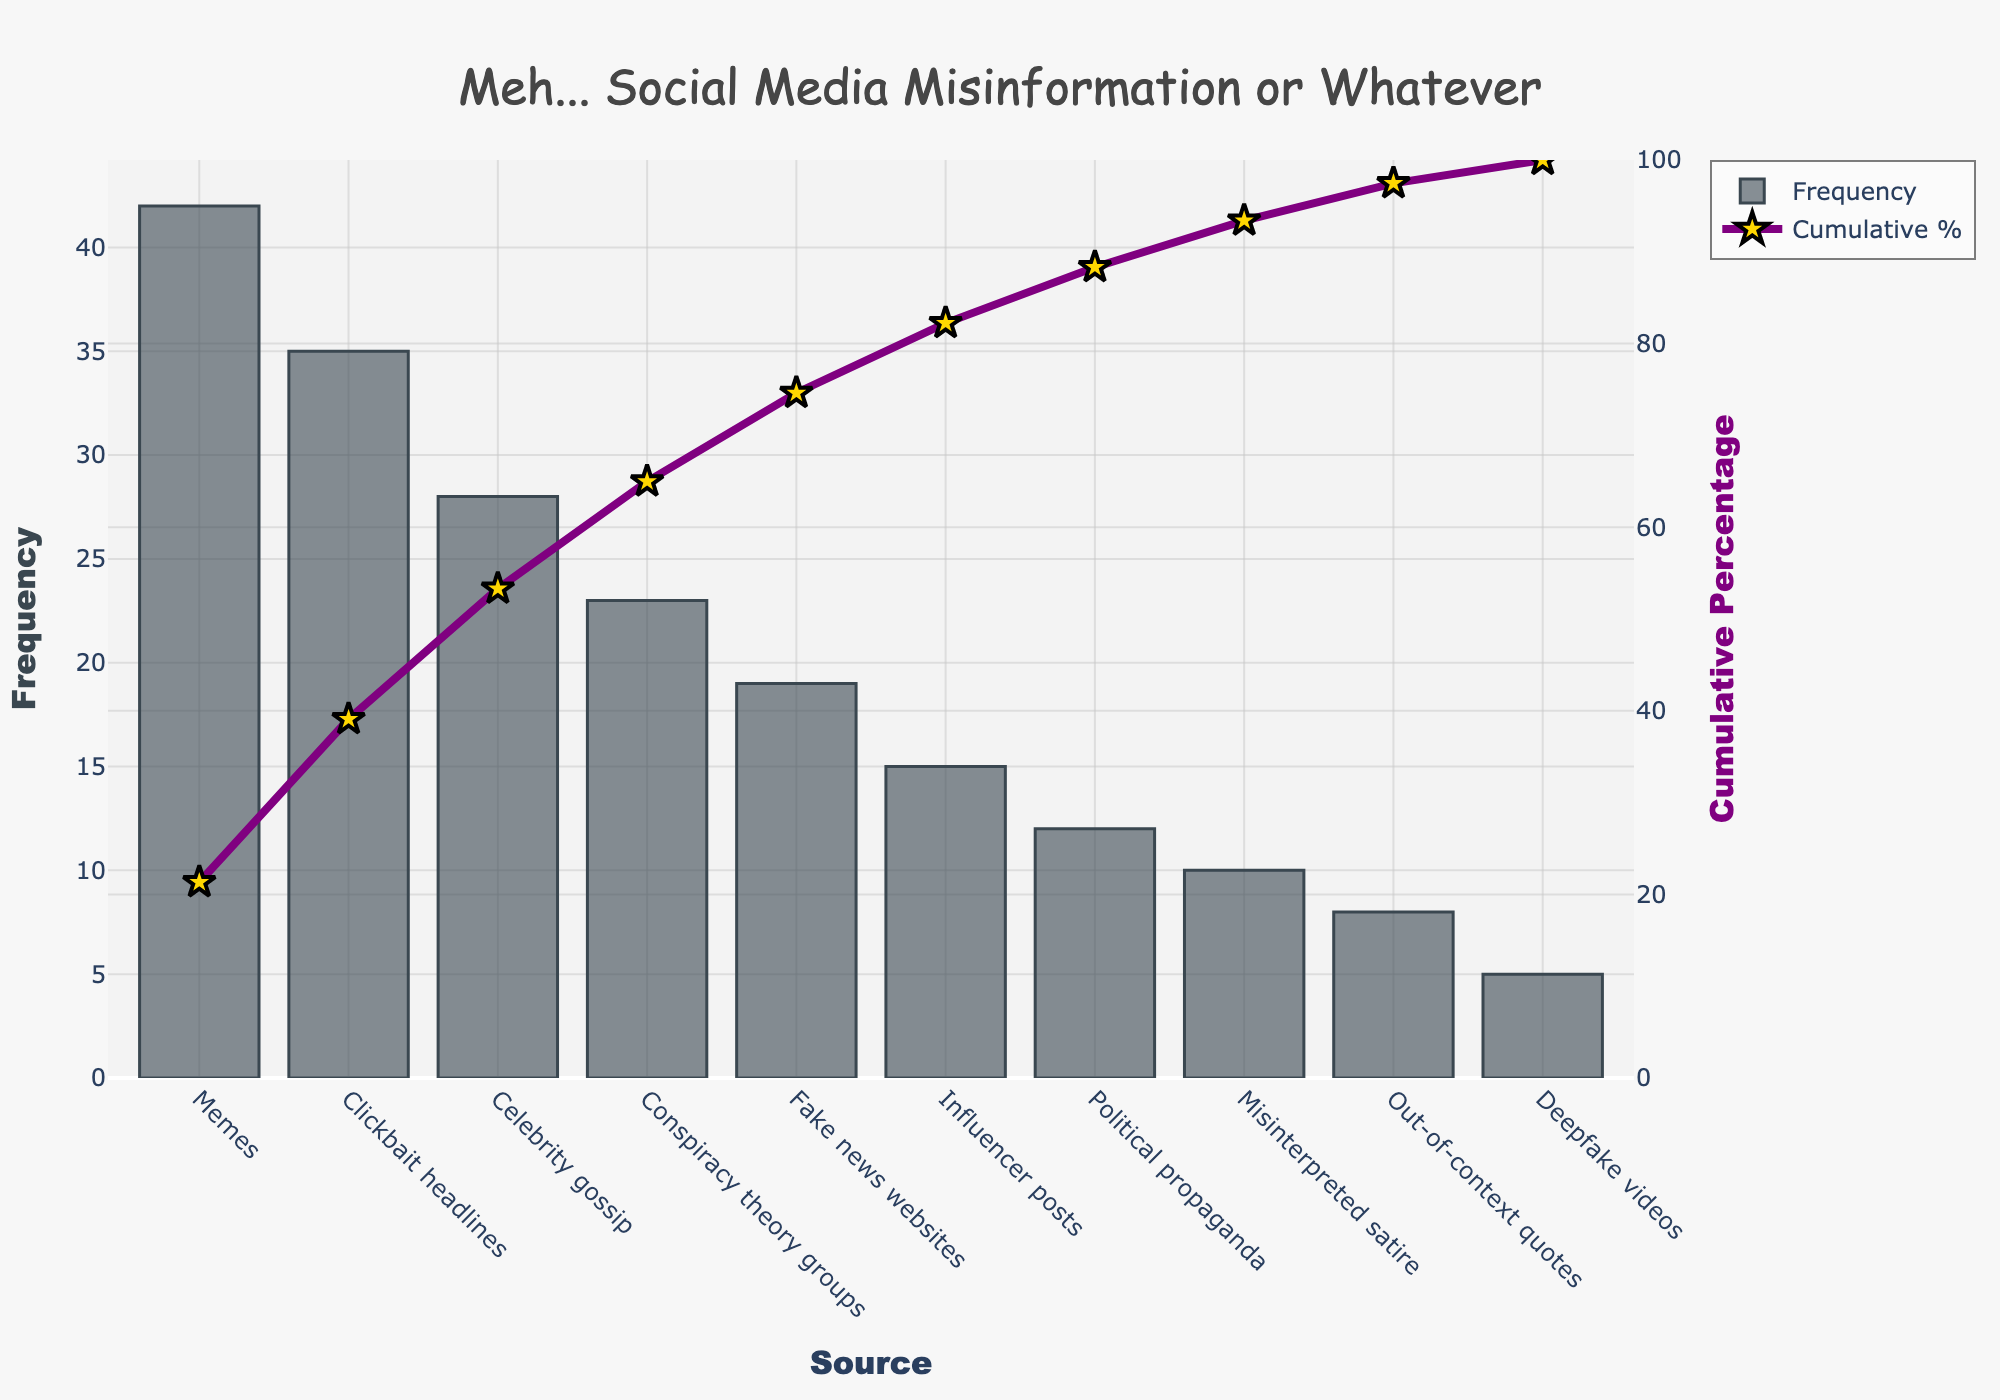What's the most common source of misinformation? Look at the bar part of the Pareto chart. The tallest bar represents the source with the highest frequency.
Answer: Memes Which source has a cumulative percentage of around 50%? Identify the point where the cumulative percentage curve crosses 50% on the y2-axis and see which source it corresponds to on the x-axis.
Answer: Celebrity gossip How much more frequent are memes compared to deepfake videos? Find the frequency of both memes (42) and deepfake videos (5), and calculate the difference: 42 - 5 = 37.
Answer: 37 Which sources together make up more than 80% of the cumulative percentage? Check the cumulative percentage line and see where it exceeds 80%. The sources up to and including clickbait headlines contribute to more than 80%.
Answer: Memes, Clickbait headlines, Celebrity gossip, Conspiracy theory groups, Fake news websites What color is used to represent the cumulative percentage line? Look at the cumulative percentage line on the chart. The line is colored in a distinct color.
Answer: Purple What is the frequency of the third most common source of misinformation? Identify the third tallest bar on the chart, which corresponds to celebrity gossip. Check the frequency value.
Answer: 28 How many sources have a frequency less than 20? Count the number of bars with a height less than 20 on the frequency axis.
Answer: 6 What is the cumulative percentage for misinterpreted satire? Find the point on the cumulative percentage line that corresponds to misinterpreted satire and read the value on the y2-axis.
Answer: Approximately 93% Which is more frequent, political propaganda or influencer posts? Compare the heights of the bars for political propaganda and influencer posts.
Answer: Influencer posts Are more than half of the sources' frequencies above 20? Count the total number of sources (10), and see how many have frequencies above 20 by looking at the heights of the bars. If more than 5 are above 20, then more than half are.
Answer: No 